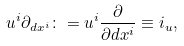Convert formula to latex. <formula><loc_0><loc_0><loc_500><loc_500>u ^ { i } \partial _ { d x ^ { i } } \colon = u ^ { i } \frac { \partial } { \partial d x ^ { i } } \equiv i _ { u } ,</formula> 